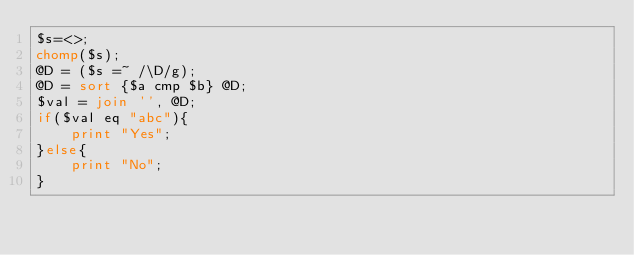Convert code to text. <code><loc_0><loc_0><loc_500><loc_500><_Perl_>$s=<>;
chomp($s);
@D = ($s =~ /\D/g);
@D = sort {$a cmp $b} @D;
$val = join '', @D;
if($val eq "abc"){
	print "Yes";
}else{
	print "No";
}</code> 